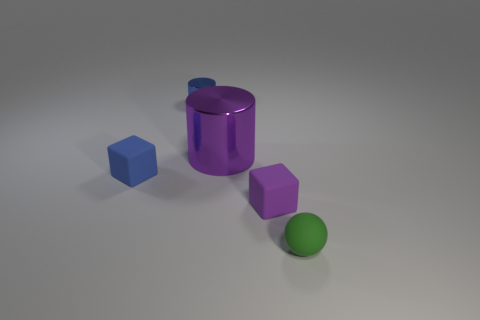Add 4 large brown rubber things. How many objects exist? 9 Subtract all spheres. How many objects are left? 4 Add 3 purple blocks. How many purple blocks exist? 4 Subtract 0 cyan balls. How many objects are left? 5 Subtract all tiny purple matte cubes. Subtract all small metallic cylinders. How many objects are left? 3 Add 3 large purple objects. How many large purple objects are left? 4 